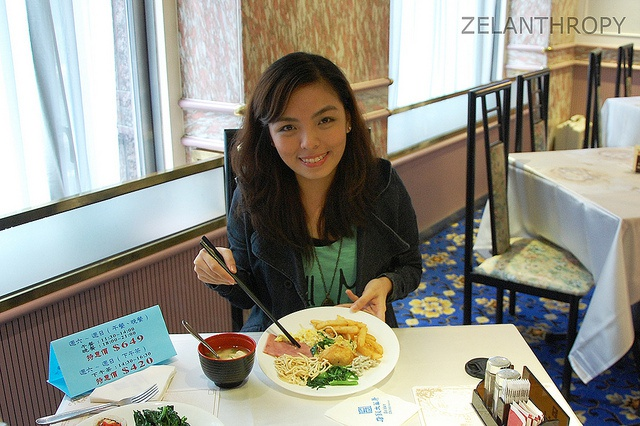Describe the objects in this image and their specific colors. I can see people in lightblue, black, brown, maroon, and darkgreen tones, dining table in lightblue, beige, darkgray, and black tones, chair in lightblue, black, gray, darkgray, and tan tones, dining table in lightblue, lightgray, and tan tones, and chair in lightblue, black, and gray tones in this image. 